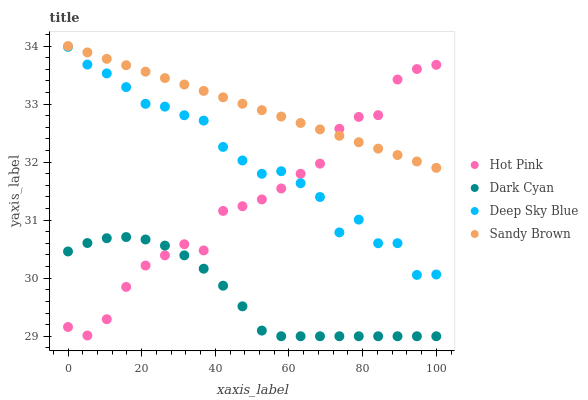Does Dark Cyan have the minimum area under the curve?
Answer yes or no. Yes. Does Sandy Brown have the maximum area under the curve?
Answer yes or no. Yes. Does Hot Pink have the minimum area under the curve?
Answer yes or no. No. Does Hot Pink have the maximum area under the curve?
Answer yes or no. No. Is Sandy Brown the smoothest?
Answer yes or no. Yes. Is Deep Sky Blue the roughest?
Answer yes or no. Yes. Is Hot Pink the smoothest?
Answer yes or no. No. Is Hot Pink the roughest?
Answer yes or no. No. Does Dark Cyan have the lowest value?
Answer yes or no. Yes. Does Hot Pink have the lowest value?
Answer yes or no. No. Does Sandy Brown have the highest value?
Answer yes or no. Yes. Does Hot Pink have the highest value?
Answer yes or no. No. Is Dark Cyan less than Sandy Brown?
Answer yes or no. Yes. Is Sandy Brown greater than Dark Cyan?
Answer yes or no. Yes. Does Hot Pink intersect Dark Cyan?
Answer yes or no. Yes. Is Hot Pink less than Dark Cyan?
Answer yes or no. No. Is Hot Pink greater than Dark Cyan?
Answer yes or no. No. Does Dark Cyan intersect Sandy Brown?
Answer yes or no. No. 